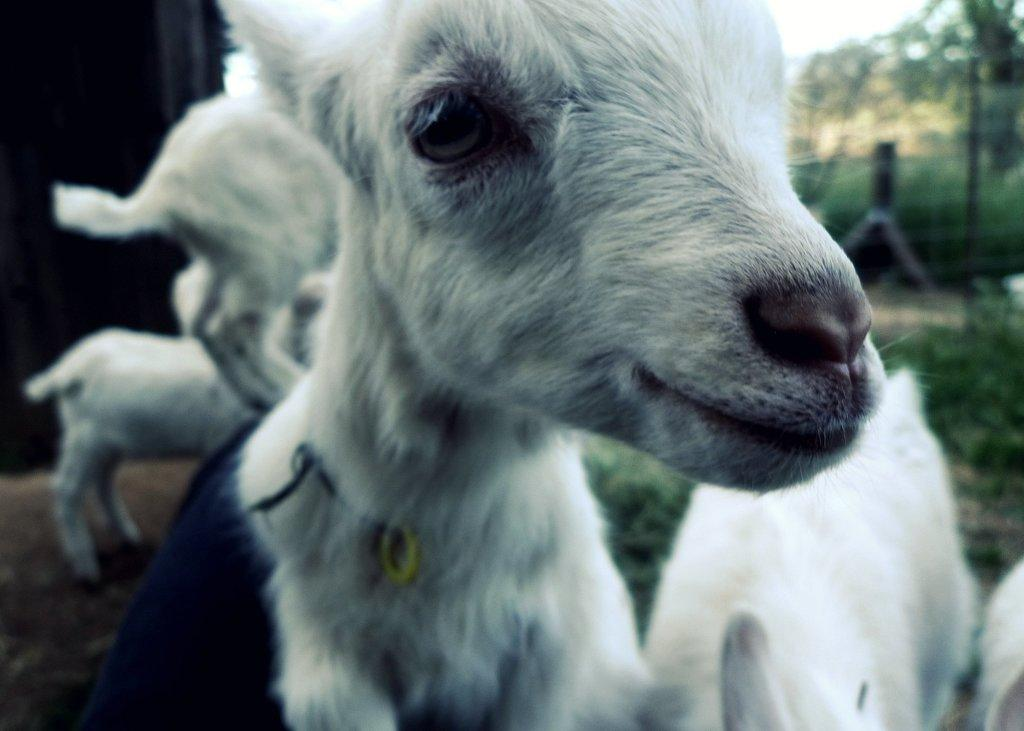What types of living organisms can be seen in the image? There are many animals in the image. What can be seen on the right side of the image? There are plants on the right side of the image. What is visible in the background of the image? There are poles, trees, and the sky visible in the background of the image. What is the color of the object on the left side of the image? There is a black color object on the left side of the image. Can you tell me which animal is wearing a hat in the image? There are no animals wearing hats in the image. How many rats can be seen in the image? There are no rats present in the image. 